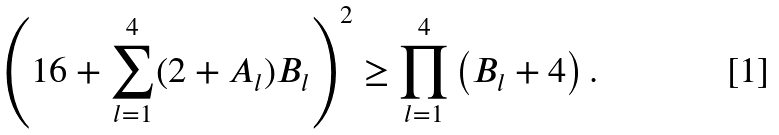<formula> <loc_0><loc_0><loc_500><loc_500>\left ( 1 6 + \sum _ { l = 1 } ^ { 4 } ( 2 + A _ { l } ) B _ { l } \right ) ^ { 2 } \geq \prod _ { l = 1 } ^ { 4 } \left ( B _ { l } + 4 \right ) .</formula> 